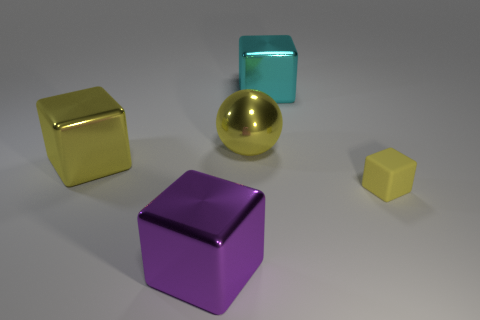Is there a metal object of the same color as the small rubber thing?
Make the answer very short. Yes. What material is the tiny yellow object?
Offer a terse response. Rubber. How many large cyan cubes are there?
Provide a succinct answer. 1. Does the large shiny block left of the purple metal cube have the same color as the big ball behind the purple thing?
Provide a succinct answer. Yes. There is a rubber thing that is the same color as the large ball; what is its size?
Your answer should be very brief. Small. How many other things are there of the same size as the purple metal block?
Keep it short and to the point. 3. What is the color of the big shiny cube behind the yellow shiny block?
Offer a very short reply. Cyan. Does the yellow block that is left of the big cyan object have the same material as the large cyan object?
Make the answer very short. Yes. What number of objects are both in front of the yellow shiny cube and on the left side of the big cyan block?
Offer a very short reply. 1. The metallic cube that is to the right of the metallic block that is in front of the yellow cube behind the rubber cube is what color?
Ensure brevity in your answer.  Cyan. 